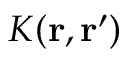<formula> <loc_0><loc_0><loc_500><loc_500>K ( { r , r ^ { \prime } } )</formula> 